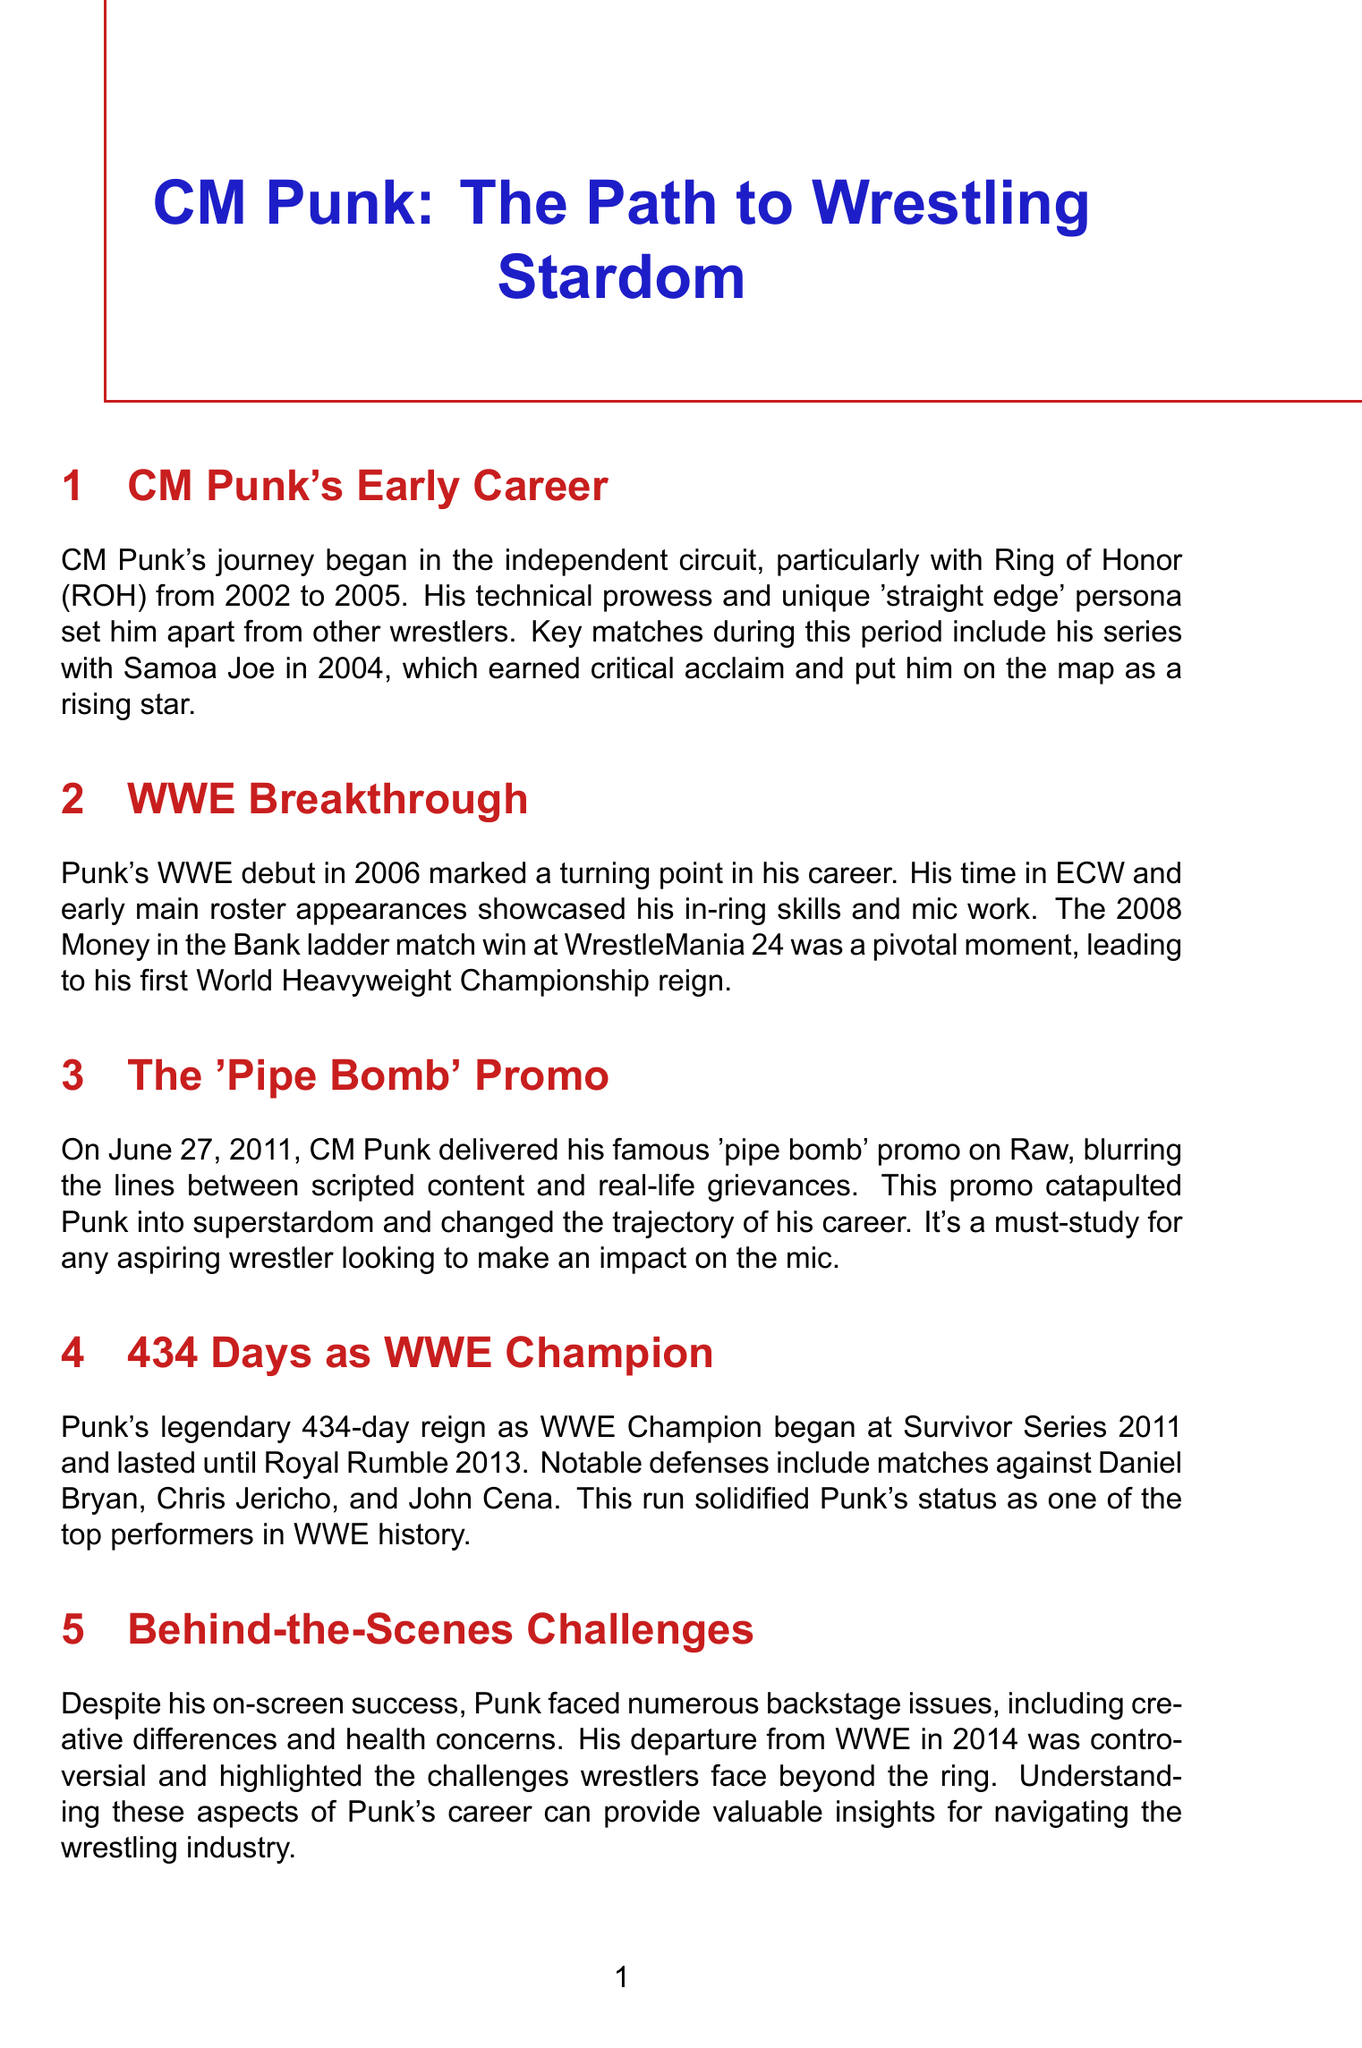What year did CM Punk begin his career in Ring of Honor? CM Punk's early career started in the independent circuit with ROH from 2002 to 2005.
Answer: 2002 What was the pivotal match that led to CM Punk's first World Heavyweight Championship reign? The 2008 Money in the Bank ladder match win at WrestleMania 24 marked a pivotal moment for Punk.
Answer: Money in the Bank ladder match What is the significance of the 'pipe bomb' promo? The 'pipe bomb' promo on June 27, 2011, catapulted Punk into superstardom.
Answer: Catapulted Punk into superstardom How many days did CM Punk reign as WWE Champion? Punk's reign as WWE Champion lasted for 434 days.
Answer: 434 days What major challenge did Punk face during his career? Punk faced numerous backstage issues, including creative differences and health concerns.
Answer: Backstage issues What does CM Punk's in-ring style combine? Punk's in-ring style combines technical wrestling, striking, and high-flying moves.
Answer: Technical wrestling, striking, and high-flying moves Which match showcased Punk's ability to perform at the highest level? The match against The Undertaker at WrestleMania 29 is a career-defining moment demonstrating this ability.
Answer: WrestleMania 29 What is one of the career lessons from CM Punk's journey? One key lesson is to stand up for your beliefs, even if it means challenging authority.
Answer: Stand up for your beliefs What was a notable aspect of Punk's return to wrestling in 2021? His return to AEW in 2021 showcased his enduring popularity and connection with fans.
Answer: Enduring popularity and connection with fans 